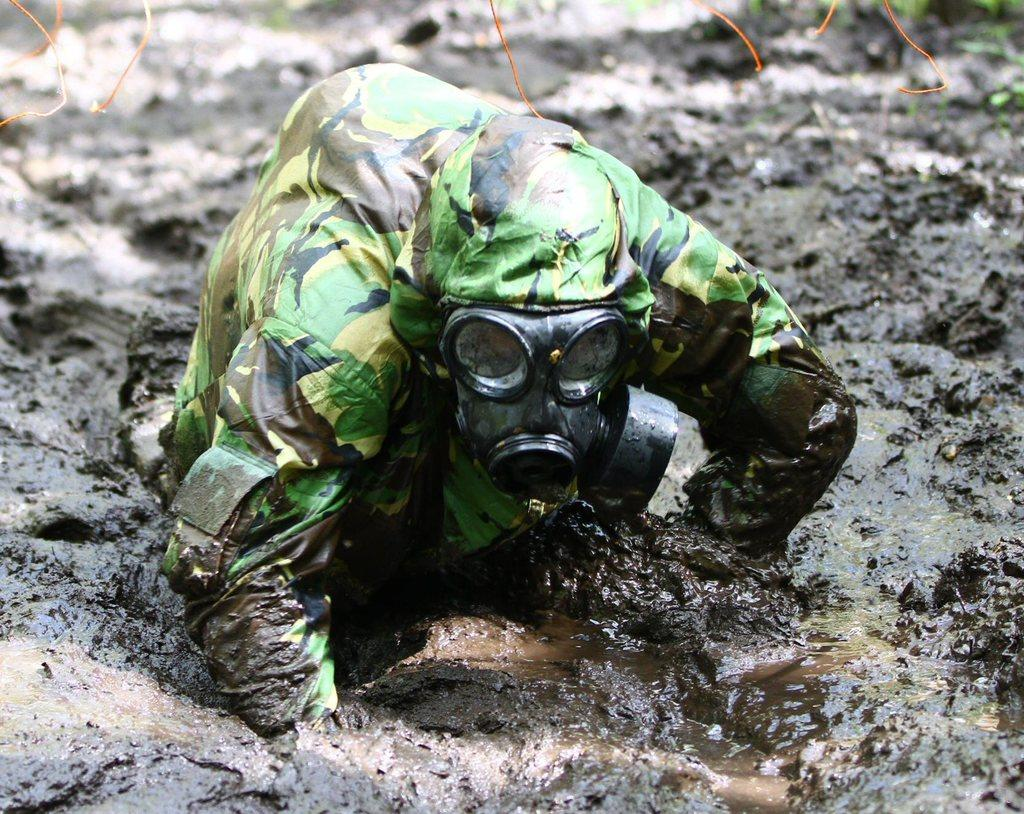What is present in the image? There is a person in the image. What can be seen at the bottom of the image? There is mud visible at the bottom of the image. What color is the harmony in the image? There is no harmony present in the image, as it is a visual medium and harmony is a concept related to music or relationships. 